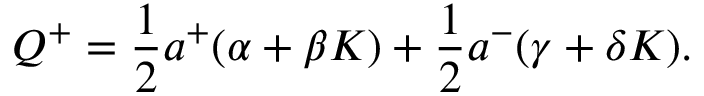Convert formula to latex. <formula><loc_0><loc_0><loc_500><loc_500>Q ^ { + } = \frac { 1 } { 2 } a ^ { + } ( \alpha + \beta K ) + \frac { 1 } { 2 } a ^ { - } ( \gamma + \delta K ) .</formula> 